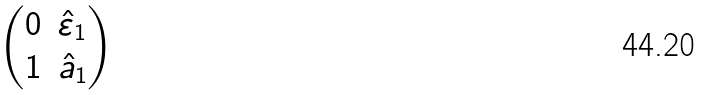<formula> <loc_0><loc_0><loc_500><loc_500>\begin{pmatrix} 0 & \hat { \varepsilon } _ { 1 } \\ 1 & \hat { a } _ { 1 } \end{pmatrix}</formula> 